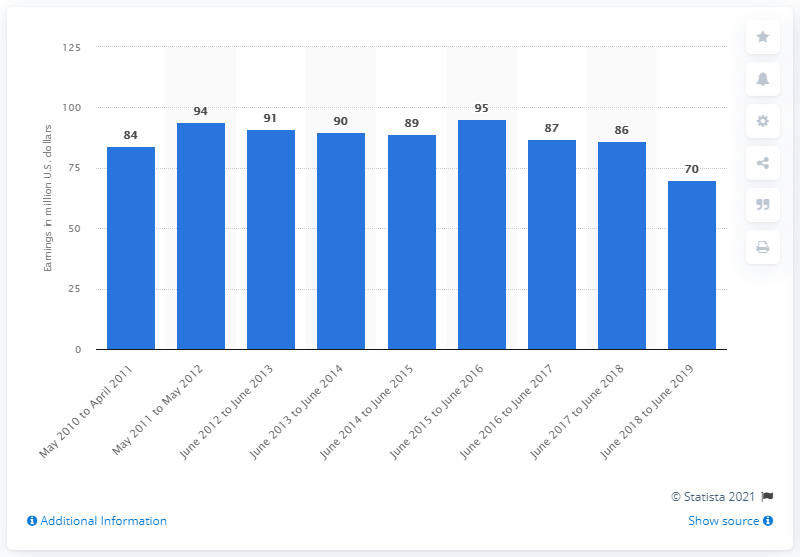Identify some key points in this picture. James Patterson earned an estimated 70 million USD between June 2018 and June 2019. 